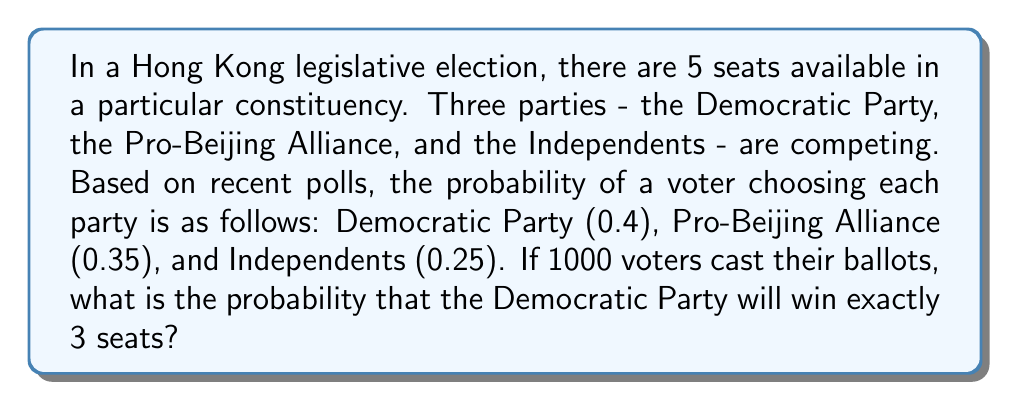Give your solution to this math problem. To solve this problem, we'll use the multinomial distribution, which is appropriate for situations with more than two possible outcomes.

Step 1: Identify the parameters
- Number of trials (voters): $n = 1000$
- Number of seats: $k = 5$
- Probabilities: $p_1 = 0.4$ (Democratic), $p_2 = 0.35$ (Pro-Beijing), $p_3 = 0.25$ (Independents)

Step 2: Calculate the probability of the Democratic Party winning exactly 3 seats
We need to sum the probabilities of all possible combinations where the Democratic Party wins 3 seats and the other two parties share the remaining 2 seats.

The multinomial probability formula is:

$$P(X_1 = x_1, X_2 = x_2, X_3 = x_3) = \frac{n!}{x_1!x_2!x_3!} p_1^{x_1} p_2^{x_2} p_3^{x_3}$$

We need to calculate:
1. P(Democratic: 3, Pro-Beijing: 2, Independents: 0)
2. P(Democratic: 3, Pro-Beijing: 1, Independents: 1)
3. P(Democratic: 3, Pro-Beijing: 0, Independents: 2)

Step 3: Calculate each probability

1. $P(3,2,0) = \frac{5!}{3!2!0!} 0.4^3 0.35^2 0.25^0 \approx 0.1344$

2. $P(3,1,1) = \frac{5!}{3!1!1!} 0.4^3 0.35^1 0.25^1 \approx 0.1200$

3. $P(3,0,2) = \frac{5!}{3!0!2!} 0.4^3 0.35^0 0.25^2 \approx 0.0214$

Step 4: Sum the probabilities
Total probability = $0.1344 + 0.1200 + 0.0214 = 0.2758$

Therefore, the probability of the Democratic Party winning exactly 3 seats is approximately 0.2758 or 27.58%.
Answer: 0.2758 